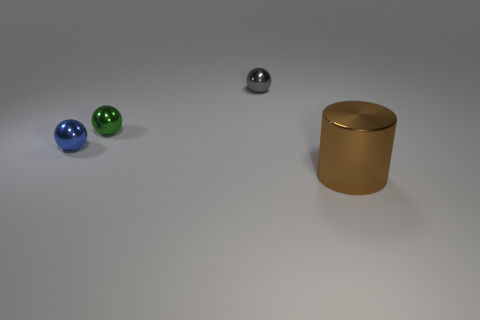Are there any other things that are the same shape as the big brown metallic thing?
Your answer should be compact. No. There is a brown object; are there any small gray shiny spheres behind it?
Provide a short and direct response. Yes. Is the size of the brown object the same as the gray shiny thing?
Your answer should be compact. No. The tiny metallic object that is on the left side of the green ball has what shape?
Ensure brevity in your answer.  Sphere. Is there a green sphere of the same size as the gray metallic ball?
Keep it short and to the point. Yes. There is a green sphere that is the same size as the gray metal ball; what material is it?
Keep it short and to the point. Metal. There is a shiny thing on the right side of the gray object; what size is it?
Offer a very short reply. Large. How big is the metallic cylinder?
Offer a very short reply. Large. There is a gray metal thing; is its size the same as the shiny sphere that is in front of the green sphere?
Keep it short and to the point. Yes. There is a thing in front of the small metallic thing that is left of the green metallic object; what color is it?
Offer a very short reply. Brown. 